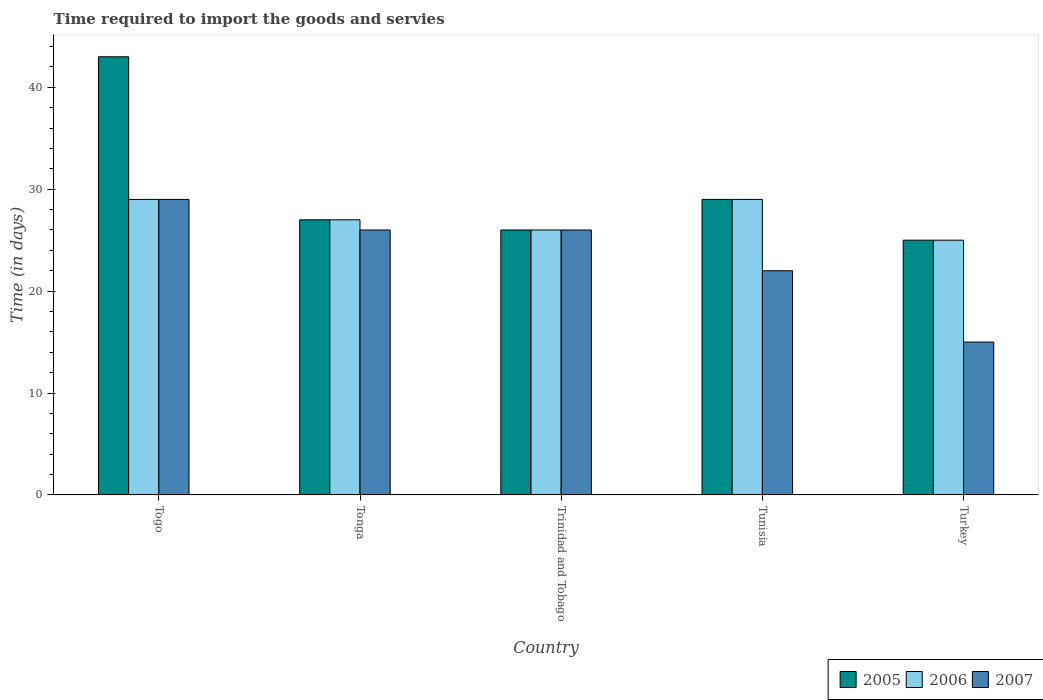Are the number of bars on each tick of the X-axis equal?
Make the answer very short. Yes. How many bars are there on the 2nd tick from the left?
Your response must be concise. 3. How many bars are there on the 5th tick from the right?
Provide a succinct answer. 3. What is the label of the 2nd group of bars from the left?
Make the answer very short. Tonga. What is the number of days required to import the goods and services in 2006 in Tunisia?
Your response must be concise. 29. In which country was the number of days required to import the goods and services in 2007 maximum?
Make the answer very short. Togo. In which country was the number of days required to import the goods and services in 2005 minimum?
Give a very brief answer. Turkey. What is the total number of days required to import the goods and services in 2006 in the graph?
Give a very brief answer. 136. What is the difference between the number of days required to import the goods and services in 2005 in Tunisia and the number of days required to import the goods and services in 2007 in Togo?
Provide a succinct answer. 0. What is the difference between the number of days required to import the goods and services of/in 2007 and number of days required to import the goods and services of/in 2006 in Tunisia?
Make the answer very short. -7. In how many countries, is the number of days required to import the goods and services in 2005 greater than 6 days?
Your response must be concise. 5. What is the ratio of the number of days required to import the goods and services in 2005 in Togo to that in Tonga?
Offer a terse response. 1.59. What is the difference between the highest and the second highest number of days required to import the goods and services in 2007?
Provide a short and direct response. -3. What is the difference between the highest and the lowest number of days required to import the goods and services in 2006?
Your answer should be very brief. 4. What does the 1st bar from the right in Turkey represents?
Your response must be concise. 2007. Are all the bars in the graph horizontal?
Offer a terse response. No. Where does the legend appear in the graph?
Your answer should be compact. Bottom right. What is the title of the graph?
Offer a terse response. Time required to import the goods and servies. Does "1969" appear as one of the legend labels in the graph?
Give a very brief answer. No. What is the label or title of the X-axis?
Make the answer very short. Country. What is the label or title of the Y-axis?
Give a very brief answer. Time (in days). What is the Time (in days) in 2006 in Togo?
Give a very brief answer. 29. What is the Time (in days) of 2007 in Togo?
Offer a very short reply. 29. What is the Time (in days) of 2007 in Tonga?
Give a very brief answer. 26. What is the Time (in days) of 2005 in Trinidad and Tobago?
Give a very brief answer. 26. What is the Time (in days) in 2006 in Trinidad and Tobago?
Offer a terse response. 26. What is the Time (in days) of 2007 in Trinidad and Tobago?
Offer a terse response. 26. What is the Time (in days) of 2005 in Tunisia?
Your answer should be compact. 29. What is the Time (in days) of 2007 in Tunisia?
Keep it short and to the point. 22. What is the Time (in days) of 2006 in Turkey?
Offer a very short reply. 25. Across all countries, what is the maximum Time (in days) of 2005?
Offer a very short reply. 43. Across all countries, what is the minimum Time (in days) of 2005?
Offer a very short reply. 25. Across all countries, what is the minimum Time (in days) of 2006?
Your response must be concise. 25. What is the total Time (in days) in 2005 in the graph?
Offer a terse response. 150. What is the total Time (in days) in 2006 in the graph?
Make the answer very short. 136. What is the total Time (in days) in 2007 in the graph?
Your response must be concise. 118. What is the difference between the Time (in days) of 2006 in Togo and that in Tonga?
Offer a very short reply. 2. What is the difference between the Time (in days) of 2007 in Togo and that in Tonga?
Offer a terse response. 3. What is the difference between the Time (in days) in 2005 in Togo and that in Trinidad and Tobago?
Your answer should be compact. 17. What is the difference between the Time (in days) in 2006 in Togo and that in Trinidad and Tobago?
Make the answer very short. 3. What is the difference between the Time (in days) in 2005 in Togo and that in Tunisia?
Your answer should be compact. 14. What is the difference between the Time (in days) in 2006 in Togo and that in Tunisia?
Your answer should be very brief. 0. What is the difference between the Time (in days) in 2007 in Togo and that in Tunisia?
Provide a succinct answer. 7. What is the difference between the Time (in days) of 2005 in Togo and that in Turkey?
Your answer should be very brief. 18. What is the difference between the Time (in days) of 2005 in Tonga and that in Trinidad and Tobago?
Ensure brevity in your answer.  1. What is the difference between the Time (in days) in 2007 in Tonga and that in Trinidad and Tobago?
Your answer should be very brief. 0. What is the difference between the Time (in days) in 2007 in Tonga and that in Tunisia?
Provide a short and direct response. 4. What is the difference between the Time (in days) in 2006 in Tonga and that in Turkey?
Offer a terse response. 2. What is the difference between the Time (in days) in 2007 in Tonga and that in Turkey?
Your response must be concise. 11. What is the difference between the Time (in days) in 2005 in Trinidad and Tobago and that in Tunisia?
Give a very brief answer. -3. What is the difference between the Time (in days) in 2006 in Trinidad and Tobago and that in Tunisia?
Your response must be concise. -3. What is the difference between the Time (in days) of 2007 in Trinidad and Tobago and that in Tunisia?
Your answer should be very brief. 4. What is the difference between the Time (in days) of 2005 in Trinidad and Tobago and that in Turkey?
Offer a terse response. 1. What is the difference between the Time (in days) in 2007 in Trinidad and Tobago and that in Turkey?
Ensure brevity in your answer.  11. What is the difference between the Time (in days) of 2005 in Togo and the Time (in days) of 2006 in Tonga?
Make the answer very short. 16. What is the difference between the Time (in days) of 2005 in Togo and the Time (in days) of 2007 in Tonga?
Provide a succinct answer. 17. What is the difference between the Time (in days) in 2006 in Togo and the Time (in days) in 2007 in Tonga?
Your response must be concise. 3. What is the difference between the Time (in days) in 2005 in Togo and the Time (in days) in 2006 in Trinidad and Tobago?
Offer a very short reply. 17. What is the difference between the Time (in days) in 2005 in Togo and the Time (in days) in 2007 in Trinidad and Tobago?
Offer a terse response. 17. What is the difference between the Time (in days) of 2006 in Togo and the Time (in days) of 2007 in Tunisia?
Make the answer very short. 7. What is the difference between the Time (in days) of 2005 in Togo and the Time (in days) of 2006 in Turkey?
Ensure brevity in your answer.  18. What is the difference between the Time (in days) in 2006 in Togo and the Time (in days) in 2007 in Turkey?
Your response must be concise. 14. What is the difference between the Time (in days) of 2005 in Tonga and the Time (in days) of 2006 in Trinidad and Tobago?
Your response must be concise. 1. What is the difference between the Time (in days) of 2005 in Tonga and the Time (in days) of 2007 in Trinidad and Tobago?
Your answer should be compact. 1. What is the difference between the Time (in days) of 2006 in Tonga and the Time (in days) of 2007 in Trinidad and Tobago?
Keep it short and to the point. 1. What is the difference between the Time (in days) of 2005 in Tonga and the Time (in days) of 2007 in Turkey?
Provide a succinct answer. 12. What is the difference between the Time (in days) of 2006 in Tonga and the Time (in days) of 2007 in Turkey?
Ensure brevity in your answer.  12. What is the difference between the Time (in days) in 2005 in Trinidad and Tobago and the Time (in days) in 2007 in Tunisia?
Provide a succinct answer. 4. What is the difference between the Time (in days) in 2005 in Trinidad and Tobago and the Time (in days) in 2006 in Turkey?
Your answer should be compact. 1. What is the difference between the Time (in days) of 2006 in Trinidad and Tobago and the Time (in days) of 2007 in Turkey?
Your answer should be compact. 11. What is the average Time (in days) in 2006 per country?
Give a very brief answer. 27.2. What is the average Time (in days) of 2007 per country?
Ensure brevity in your answer.  23.6. What is the difference between the Time (in days) in 2005 and Time (in days) in 2006 in Togo?
Provide a succinct answer. 14. What is the difference between the Time (in days) in 2005 and Time (in days) in 2007 in Togo?
Provide a succinct answer. 14. What is the difference between the Time (in days) of 2006 and Time (in days) of 2007 in Togo?
Your response must be concise. 0. What is the difference between the Time (in days) in 2005 and Time (in days) in 2006 in Tonga?
Your answer should be compact. 0. What is the difference between the Time (in days) of 2005 and Time (in days) of 2007 in Tonga?
Ensure brevity in your answer.  1. What is the difference between the Time (in days) in 2006 and Time (in days) in 2007 in Tonga?
Your answer should be compact. 1. What is the difference between the Time (in days) of 2005 and Time (in days) of 2007 in Trinidad and Tobago?
Give a very brief answer. 0. What is the difference between the Time (in days) of 2005 and Time (in days) of 2007 in Turkey?
Offer a terse response. 10. What is the difference between the Time (in days) of 2006 and Time (in days) of 2007 in Turkey?
Your answer should be very brief. 10. What is the ratio of the Time (in days) in 2005 in Togo to that in Tonga?
Provide a succinct answer. 1.59. What is the ratio of the Time (in days) of 2006 in Togo to that in Tonga?
Provide a short and direct response. 1.07. What is the ratio of the Time (in days) in 2007 in Togo to that in Tonga?
Your answer should be compact. 1.12. What is the ratio of the Time (in days) of 2005 in Togo to that in Trinidad and Tobago?
Ensure brevity in your answer.  1.65. What is the ratio of the Time (in days) of 2006 in Togo to that in Trinidad and Tobago?
Your answer should be very brief. 1.12. What is the ratio of the Time (in days) of 2007 in Togo to that in Trinidad and Tobago?
Your answer should be very brief. 1.12. What is the ratio of the Time (in days) in 2005 in Togo to that in Tunisia?
Offer a very short reply. 1.48. What is the ratio of the Time (in days) of 2006 in Togo to that in Tunisia?
Make the answer very short. 1. What is the ratio of the Time (in days) of 2007 in Togo to that in Tunisia?
Your answer should be very brief. 1.32. What is the ratio of the Time (in days) of 2005 in Togo to that in Turkey?
Keep it short and to the point. 1.72. What is the ratio of the Time (in days) of 2006 in Togo to that in Turkey?
Keep it short and to the point. 1.16. What is the ratio of the Time (in days) of 2007 in Togo to that in Turkey?
Provide a short and direct response. 1.93. What is the ratio of the Time (in days) of 2005 in Tonga to that in Trinidad and Tobago?
Keep it short and to the point. 1.04. What is the ratio of the Time (in days) of 2007 in Tonga to that in Trinidad and Tobago?
Your answer should be compact. 1. What is the ratio of the Time (in days) in 2005 in Tonga to that in Tunisia?
Give a very brief answer. 0.93. What is the ratio of the Time (in days) in 2007 in Tonga to that in Tunisia?
Provide a succinct answer. 1.18. What is the ratio of the Time (in days) in 2005 in Tonga to that in Turkey?
Provide a short and direct response. 1.08. What is the ratio of the Time (in days) of 2006 in Tonga to that in Turkey?
Your response must be concise. 1.08. What is the ratio of the Time (in days) in 2007 in Tonga to that in Turkey?
Your answer should be very brief. 1.73. What is the ratio of the Time (in days) of 2005 in Trinidad and Tobago to that in Tunisia?
Provide a short and direct response. 0.9. What is the ratio of the Time (in days) of 2006 in Trinidad and Tobago to that in Tunisia?
Give a very brief answer. 0.9. What is the ratio of the Time (in days) of 2007 in Trinidad and Tobago to that in Tunisia?
Ensure brevity in your answer.  1.18. What is the ratio of the Time (in days) of 2005 in Trinidad and Tobago to that in Turkey?
Provide a succinct answer. 1.04. What is the ratio of the Time (in days) in 2007 in Trinidad and Tobago to that in Turkey?
Offer a very short reply. 1.73. What is the ratio of the Time (in days) in 2005 in Tunisia to that in Turkey?
Keep it short and to the point. 1.16. What is the ratio of the Time (in days) of 2006 in Tunisia to that in Turkey?
Your answer should be very brief. 1.16. What is the ratio of the Time (in days) of 2007 in Tunisia to that in Turkey?
Your response must be concise. 1.47. What is the difference between the highest and the second highest Time (in days) of 2005?
Your answer should be compact. 14. What is the difference between the highest and the lowest Time (in days) of 2005?
Give a very brief answer. 18. 